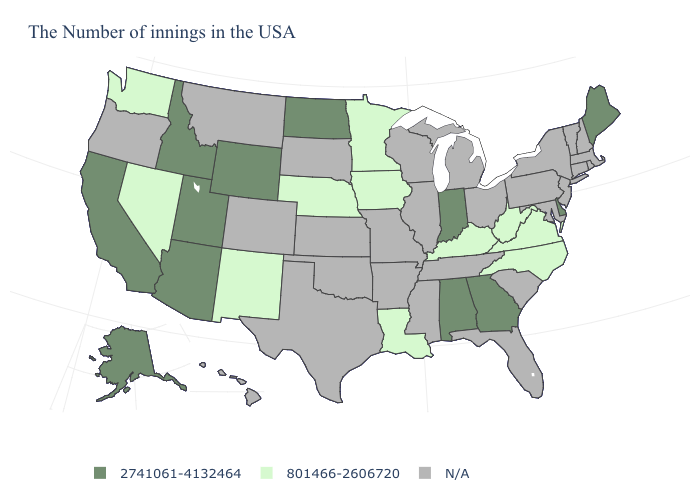What is the value of Oregon?
Quick response, please. N/A. How many symbols are there in the legend?
Short answer required. 3. Name the states that have a value in the range 801466-2606720?
Be succinct. Virginia, North Carolina, West Virginia, Kentucky, Louisiana, Minnesota, Iowa, Nebraska, New Mexico, Nevada, Washington. Which states have the lowest value in the USA?
Write a very short answer. Virginia, North Carolina, West Virginia, Kentucky, Louisiana, Minnesota, Iowa, Nebraska, New Mexico, Nevada, Washington. Which states hav the highest value in the Northeast?
Quick response, please. Maine. Which states hav the highest value in the South?
Quick response, please. Delaware, Georgia, Alabama. What is the value of Kentucky?
Give a very brief answer. 801466-2606720. What is the value of Connecticut?
Keep it brief. N/A. Name the states that have a value in the range 801466-2606720?
Keep it brief. Virginia, North Carolina, West Virginia, Kentucky, Louisiana, Minnesota, Iowa, Nebraska, New Mexico, Nevada, Washington. Does the map have missing data?
Write a very short answer. Yes. What is the lowest value in the USA?
Short answer required. 801466-2606720. What is the highest value in the West ?
Short answer required. 2741061-4132464. Which states hav the highest value in the South?
Short answer required. Delaware, Georgia, Alabama. Name the states that have a value in the range 2741061-4132464?
Keep it brief. Maine, Delaware, Georgia, Indiana, Alabama, North Dakota, Wyoming, Utah, Arizona, Idaho, California, Alaska. Name the states that have a value in the range N/A?
Short answer required. Massachusetts, Rhode Island, New Hampshire, Vermont, Connecticut, New York, New Jersey, Maryland, Pennsylvania, South Carolina, Ohio, Florida, Michigan, Tennessee, Wisconsin, Illinois, Mississippi, Missouri, Arkansas, Kansas, Oklahoma, Texas, South Dakota, Colorado, Montana, Oregon, Hawaii. 